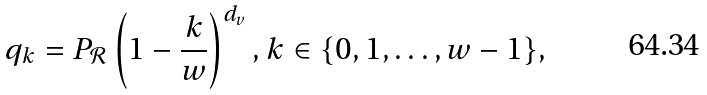<formula> <loc_0><loc_0><loc_500><loc_500>q _ { k } = P _ { \mathcal { R } } \left ( 1 - \frac { k } { w } \right ) ^ { d _ { v } } , k \in \{ 0 , 1 , \dots , w - 1 \} ,</formula> 